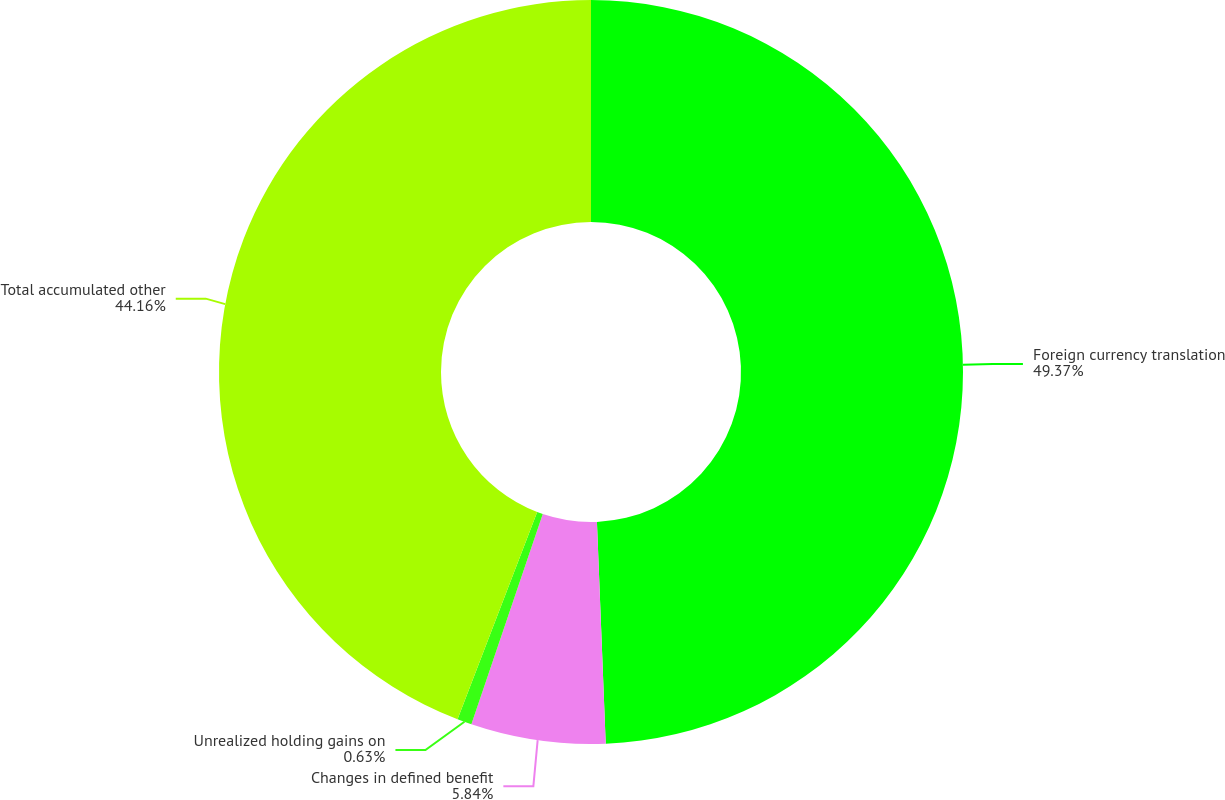Convert chart. <chart><loc_0><loc_0><loc_500><loc_500><pie_chart><fcel>Foreign currency translation<fcel>Changes in defined benefit<fcel>Unrealized holding gains on<fcel>Total accumulated other<nl><fcel>49.37%<fcel>5.84%<fcel>0.63%<fcel>44.16%<nl></chart> 